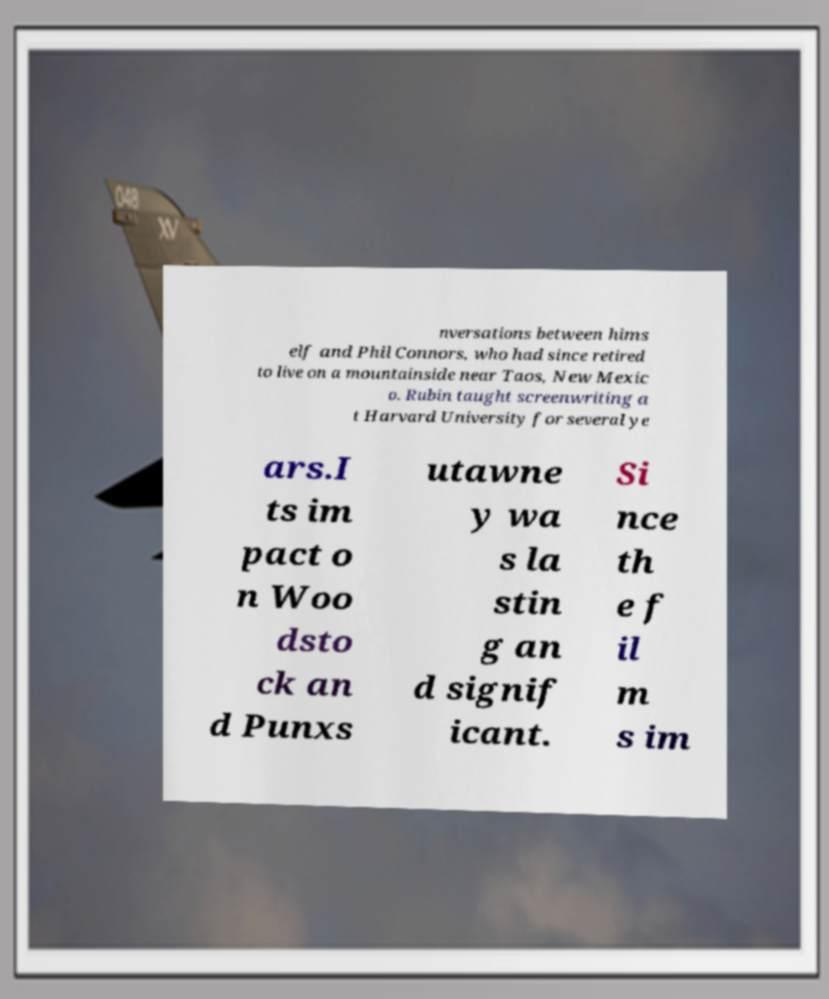Can you read and provide the text displayed in the image?This photo seems to have some interesting text. Can you extract and type it out for me? nversations between hims elf and Phil Connors, who had since retired to live on a mountainside near Taos, New Mexic o. Rubin taught screenwriting a t Harvard University for several ye ars.I ts im pact o n Woo dsto ck an d Punxs utawne y wa s la stin g an d signif icant. Si nce th e f il m s im 